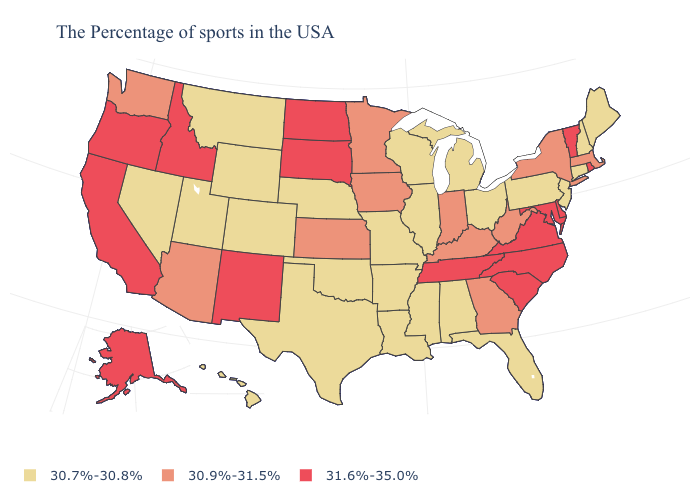Does New York have a higher value than Vermont?
Answer briefly. No. Does the first symbol in the legend represent the smallest category?
Short answer required. Yes. Does Maryland have a higher value than Delaware?
Answer briefly. No. What is the highest value in the USA?
Concise answer only. 31.6%-35.0%. Which states have the highest value in the USA?
Be succinct. Rhode Island, Vermont, Delaware, Maryland, Virginia, North Carolina, South Carolina, Tennessee, South Dakota, North Dakota, New Mexico, Idaho, California, Oregon, Alaska. Name the states that have a value in the range 30.9%-31.5%?
Concise answer only. Massachusetts, New York, West Virginia, Georgia, Kentucky, Indiana, Minnesota, Iowa, Kansas, Arizona, Washington. What is the value of Wyoming?
Write a very short answer. 30.7%-30.8%. What is the value of Tennessee?
Quick response, please. 31.6%-35.0%. Does Virginia have the lowest value in the South?
Quick response, please. No. Which states have the lowest value in the USA?
Short answer required. Maine, New Hampshire, Connecticut, New Jersey, Pennsylvania, Ohio, Florida, Michigan, Alabama, Wisconsin, Illinois, Mississippi, Louisiana, Missouri, Arkansas, Nebraska, Oklahoma, Texas, Wyoming, Colorado, Utah, Montana, Nevada, Hawaii. Does Massachusetts have the lowest value in the Northeast?
Keep it brief. No. Does New Mexico have the lowest value in the USA?
Quick response, please. No. Is the legend a continuous bar?
Quick response, please. No. What is the highest value in the MidWest ?
Answer briefly. 31.6%-35.0%. 